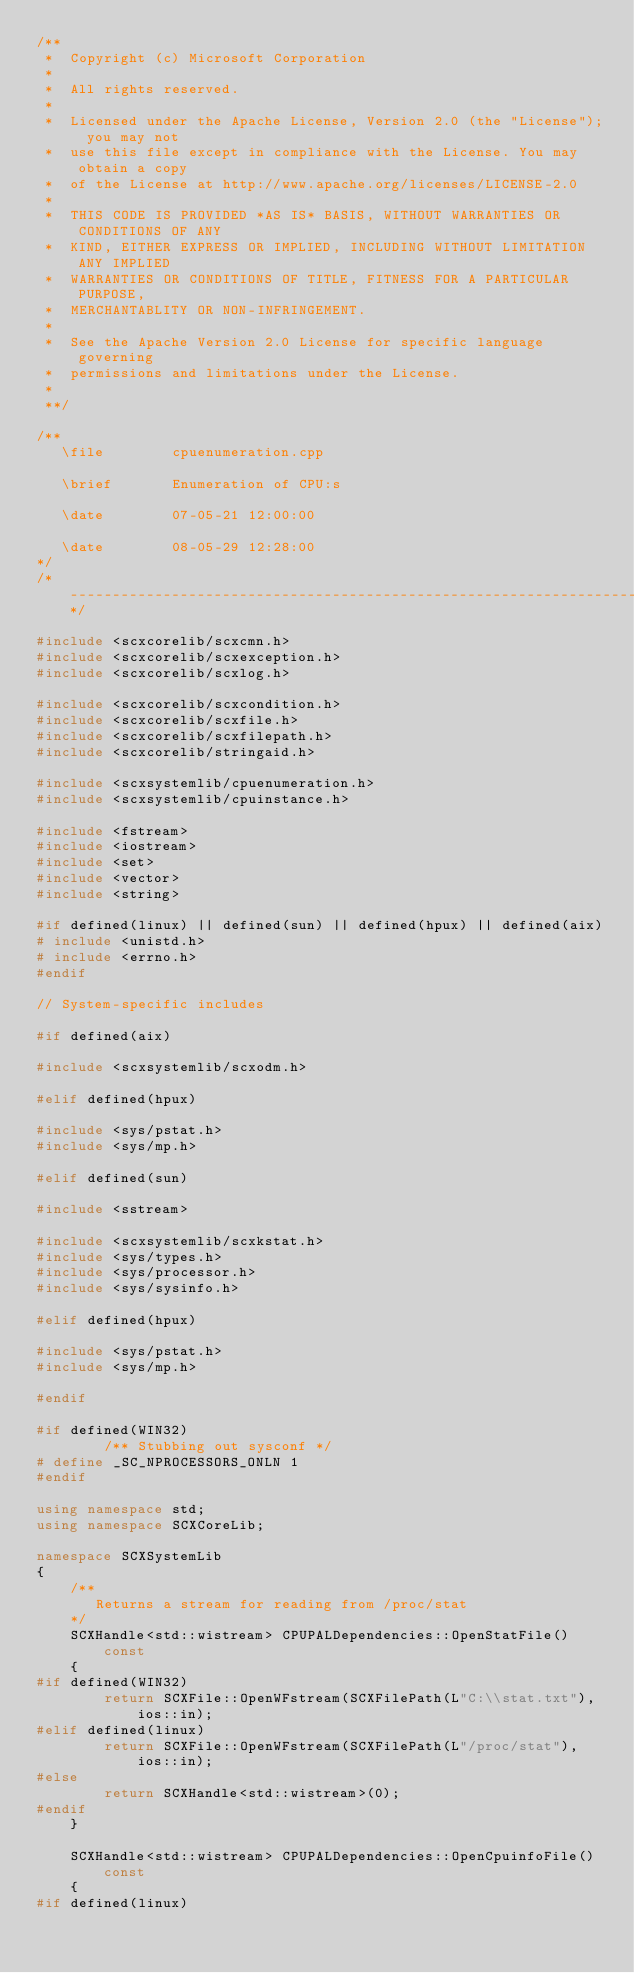Convert code to text. <code><loc_0><loc_0><loc_500><loc_500><_C++_>/**
 *  Copyright (c) Microsoft Corporation
 *
 *  All rights reserved.
 *
 *  Licensed under the Apache License, Version 2.0 (the "License"); you may not
 *  use this file except in compliance with the License. You may obtain a copy
 *  of the License at http://www.apache.org/licenses/LICENSE-2.0
 *
 *  THIS CODE IS PROVIDED *AS IS* BASIS, WITHOUT WARRANTIES OR CONDITIONS OF ANY
 *  KIND, EITHER EXPRESS OR IMPLIED, INCLUDING WITHOUT LIMITATION ANY IMPLIED
 *  WARRANTIES OR CONDITIONS OF TITLE, FITNESS FOR A PARTICULAR PURPOSE,
 *  MERCHANTABLITY OR NON-INFRINGEMENT.
 *
 *  See the Apache Version 2.0 License for specific language governing
 *  permissions and limitations under the License.
 *
 **/

/**
   \file        cpuenumeration.cpp

   \brief       Enumeration of CPU:s

   \date        07-05-21 12:00:00

   \date        08-05-29 12:28:00
*/
/*----------------------------------------------------------------------------*/

#include <scxcorelib/scxcmn.h>
#include <scxcorelib/scxexception.h>
#include <scxcorelib/scxlog.h>

#include <scxcorelib/scxcondition.h>
#include <scxcorelib/scxfile.h>
#include <scxcorelib/scxfilepath.h>
#include <scxcorelib/stringaid.h>

#include <scxsystemlib/cpuenumeration.h>
#include <scxsystemlib/cpuinstance.h>

#include <fstream>
#include <iostream>
#include <set>
#include <vector>
#include <string>

#if defined(linux) || defined(sun) || defined(hpux) || defined(aix)
# include <unistd.h>
# include <errno.h>
#endif

// System-specific includes

#if defined(aix)

#include <scxsystemlib/scxodm.h>

#elif defined(hpux)

#include <sys/pstat.h>
#include <sys/mp.h>

#elif defined(sun)

#include <sstream>

#include <scxsystemlib/scxkstat.h>
#include <sys/types.h>
#include <sys/processor.h>
#include <sys/sysinfo.h>

#elif defined(hpux)

#include <sys/pstat.h>
#include <sys/mp.h>

#endif

#if defined(WIN32)
        /** Stubbing out sysconf */
# define _SC_NPROCESSORS_ONLN 1
#endif

using namespace std;
using namespace SCXCoreLib;

namespace SCXSystemLib
{
    /**
       Returns a stream for reading from /proc/stat
    */
    SCXHandle<std::wistream> CPUPALDependencies::OpenStatFile() const
    {
#if defined(WIN32)
        return SCXFile::OpenWFstream(SCXFilePath(L"C:\\stat.txt"), ios::in);
#elif defined(linux)
        return SCXFile::OpenWFstream(SCXFilePath(L"/proc/stat"), ios::in);
#else
        return SCXHandle<std::wistream>(0);
#endif
    }

    SCXHandle<std::wistream> CPUPALDependencies::OpenCpuinfoFile() const
    {
#if defined(linux)</code> 